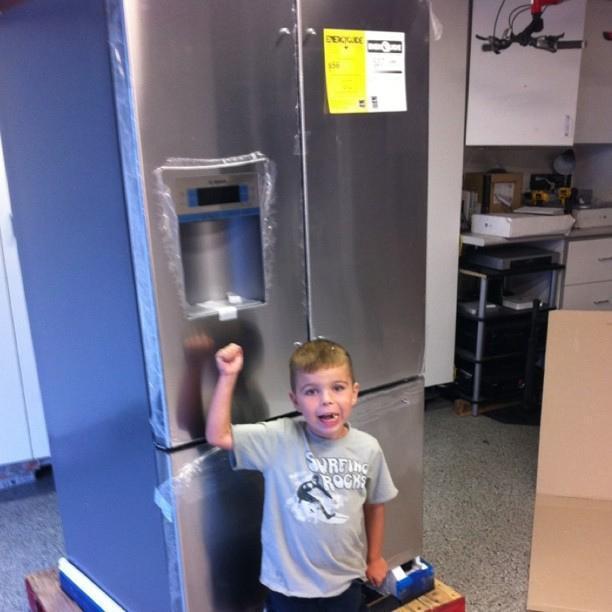How many giraffes are there?
Give a very brief answer. 0. 